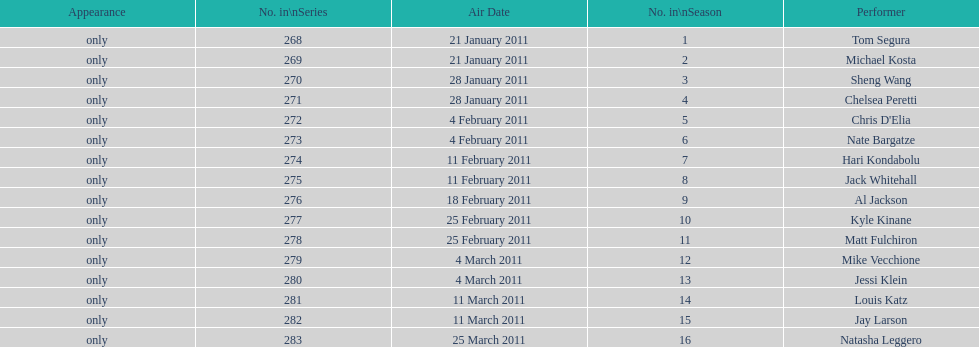Did al jackson air before or after kyle kinane? Before. Would you mind parsing the complete table? {'header': ['Appearance', 'No. in\\nSeries', 'Air Date', 'No. in\\nSeason', 'Performer'], 'rows': [['only', '268', '21 January 2011', '1', 'Tom Segura'], ['only', '269', '21 January 2011', '2', 'Michael Kosta'], ['only', '270', '28 January 2011', '3', 'Sheng Wang'], ['only', '271', '28 January 2011', '4', 'Chelsea Peretti'], ['only', '272', '4 February 2011', '5', "Chris D'Elia"], ['only', '273', '4 February 2011', '6', 'Nate Bargatze'], ['only', '274', '11 February 2011', '7', 'Hari Kondabolu'], ['only', '275', '11 February 2011', '8', 'Jack Whitehall'], ['only', '276', '18 February 2011', '9', 'Al Jackson'], ['only', '277', '25 February 2011', '10', 'Kyle Kinane'], ['only', '278', '25 February 2011', '11', 'Matt Fulchiron'], ['only', '279', '4 March 2011', '12', 'Mike Vecchione'], ['only', '280', '4 March 2011', '13', 'Jessi Klein'], ['only', '281', '11 March 2011', '14', 'Louis Katz'], ['only', '282', '11 March 2011', '15', 'Jay Larson'], ['only', '283', '25 March 2011', '16', 'Natasha Leggero']]} 